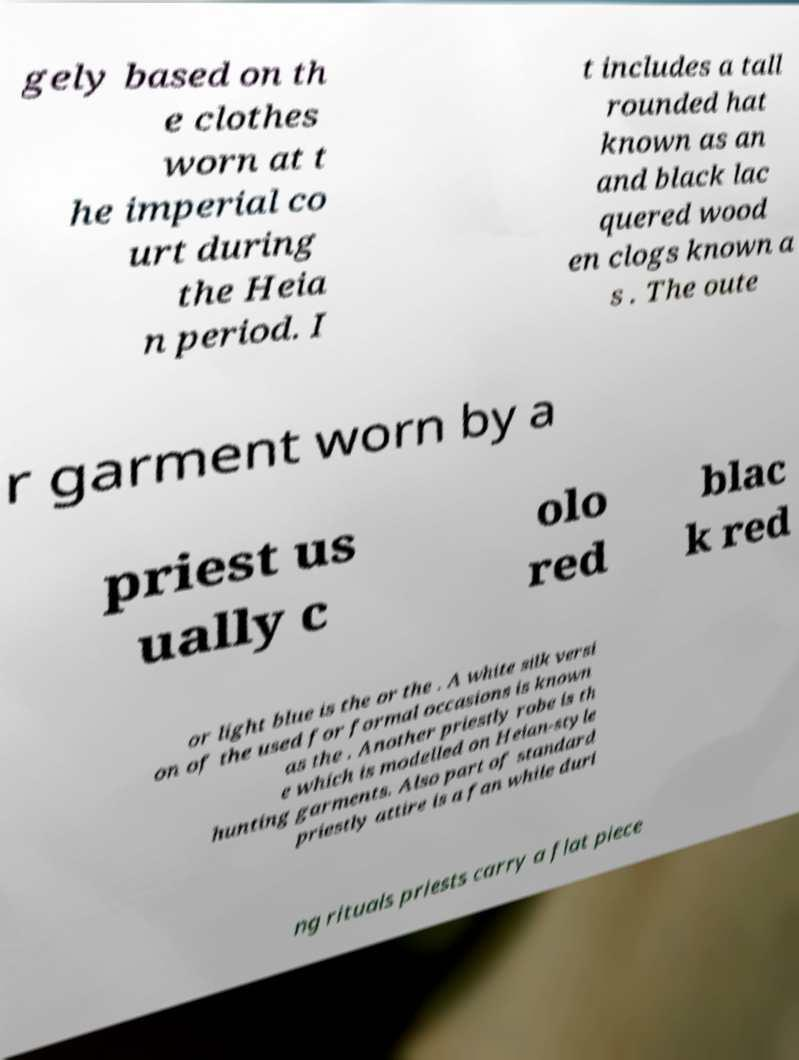Could you extract and type out the text from this image? gely based on th e clothes worn at t he imperial co urt during the Heia n period. I t includes a tall rounded hat known as an and black lac quered wood en clogs known a s . The oute r garment worn by a priest us ually c olo red blac k red or light blue is the or the . A white silk versi on of the used for formal occasions is known as the . Another priestly robe is th e which is modelled on Heian-style hunting garments. Also part of standard priestly attire is a fan while duri ng rituals priests carry a flat piece 